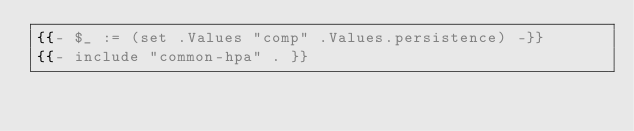Convert code to text. <code><loc_0><loc_0><loc_500><loc_500><_YAML_>{{- $_ := (set .Values "comp" .Values.persistence) -}}
{{- include "common-hpa" . }}
</code> 